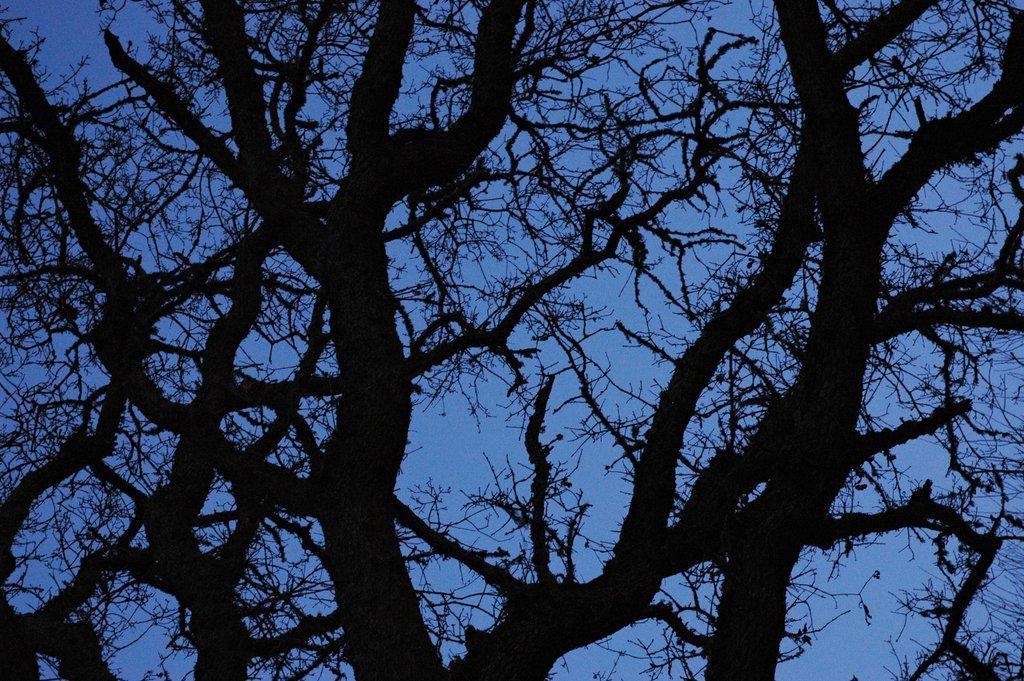Can you describe this image briefly? In this image there is a tree, in the background there is the sky. 